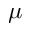<formula> <loc_0><loc_0><loc_500><loc_500>\mu</formula> 